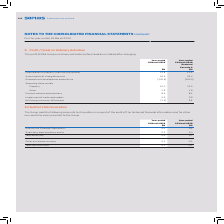According to Sophos Group's financial document, What did the Group pay the following amounts to its auditor in respect to? in respect of the audit of the historical financial information and for other non-audit services provided to the Group.. The document states: "he Group paid the following amounts to its auditor in respect of the audit of the historical financial information and for other non-audit services pr..." Also, What is the Audit of the Financial Statements fees for 2019? According to the financial document, 0.4 (in millions). The relevant text states: "Audit of the Financial Statements 0.4 0.4..." Also, What are the items under Total audit fees in the table? The document shows two values: Audit of the Financial Statements and Subsidiary local statutory audits. From the document: "Audit of the Financial Statements 0.4 0.4 Subsidiary local statutory audits 0.2 0.3..." Additionally, In which year was the amount of Total audit fees larger? According to the financial document, 2018. The relevant text states: "The profit (2018: loss) on ordinary activities before taxation is stated after charging:..." Also, can you calculate: What was the change in Total audit fees in 2019 from 2018? Based on the calculation: 0.6-0.7, the result is -0.1 (in millions). This is based on the information: "Total audit fees 0.6 0.7 Total audit fees 0.6 0.7..." The key data points involved are: 0.6, 0.7. Also, can you calculate: What was the percentage change in Total audit fees in 2019 from 2018? To answer this question, I need to perform calculations using the financial data. The calculation is: (0.6-0.7)/0.7, which equals -14.29 (percentage). This is based on the information: "Total audit fees 0.6 0.7 Total audit fees 0.6 0.7..." The key data points involved are: 0.6, 0.7. 